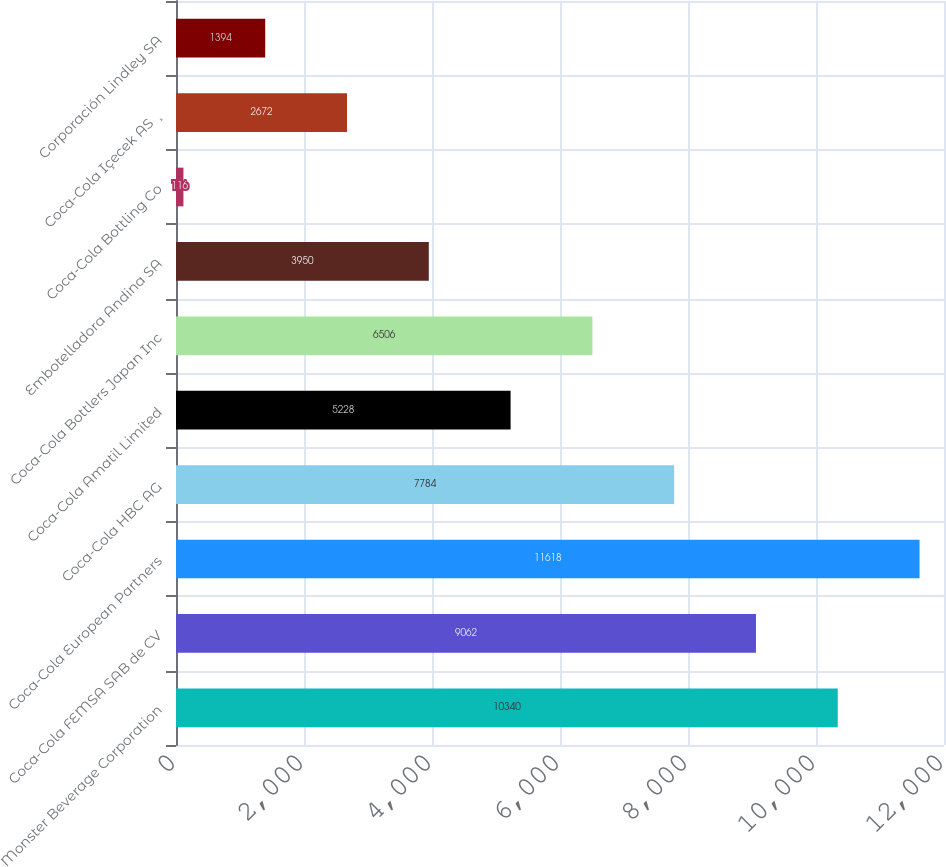Convert chart to OTSL. <chart><loc_0><loc_0><loc_500><loc_500><bar_chart><fcel>Monster Beverage Corporation<fcel>Coca-Cola FEMSA SAB de CV<fcel>Coca-Cola European Partners<fcel>Coca-Cola HBC AG<fcel>Coca-Cola Amatil Limited<fcel>Coca-Cola Bottlers Japan Inc<fcel>Embotelladora Andina SA<fcel>Coca-Cola Bottling Co<fcel>Coca-Cola Içecek AS ¸<fcel>Corporación Lindley SA<nl><fcel>10340<fcel>9062<fcel>11618<fcel>7784<fcel>5228<fcel>6506<fcel>3950<fcel>116<fcel>2672<fcel>1394<nl></chart> 